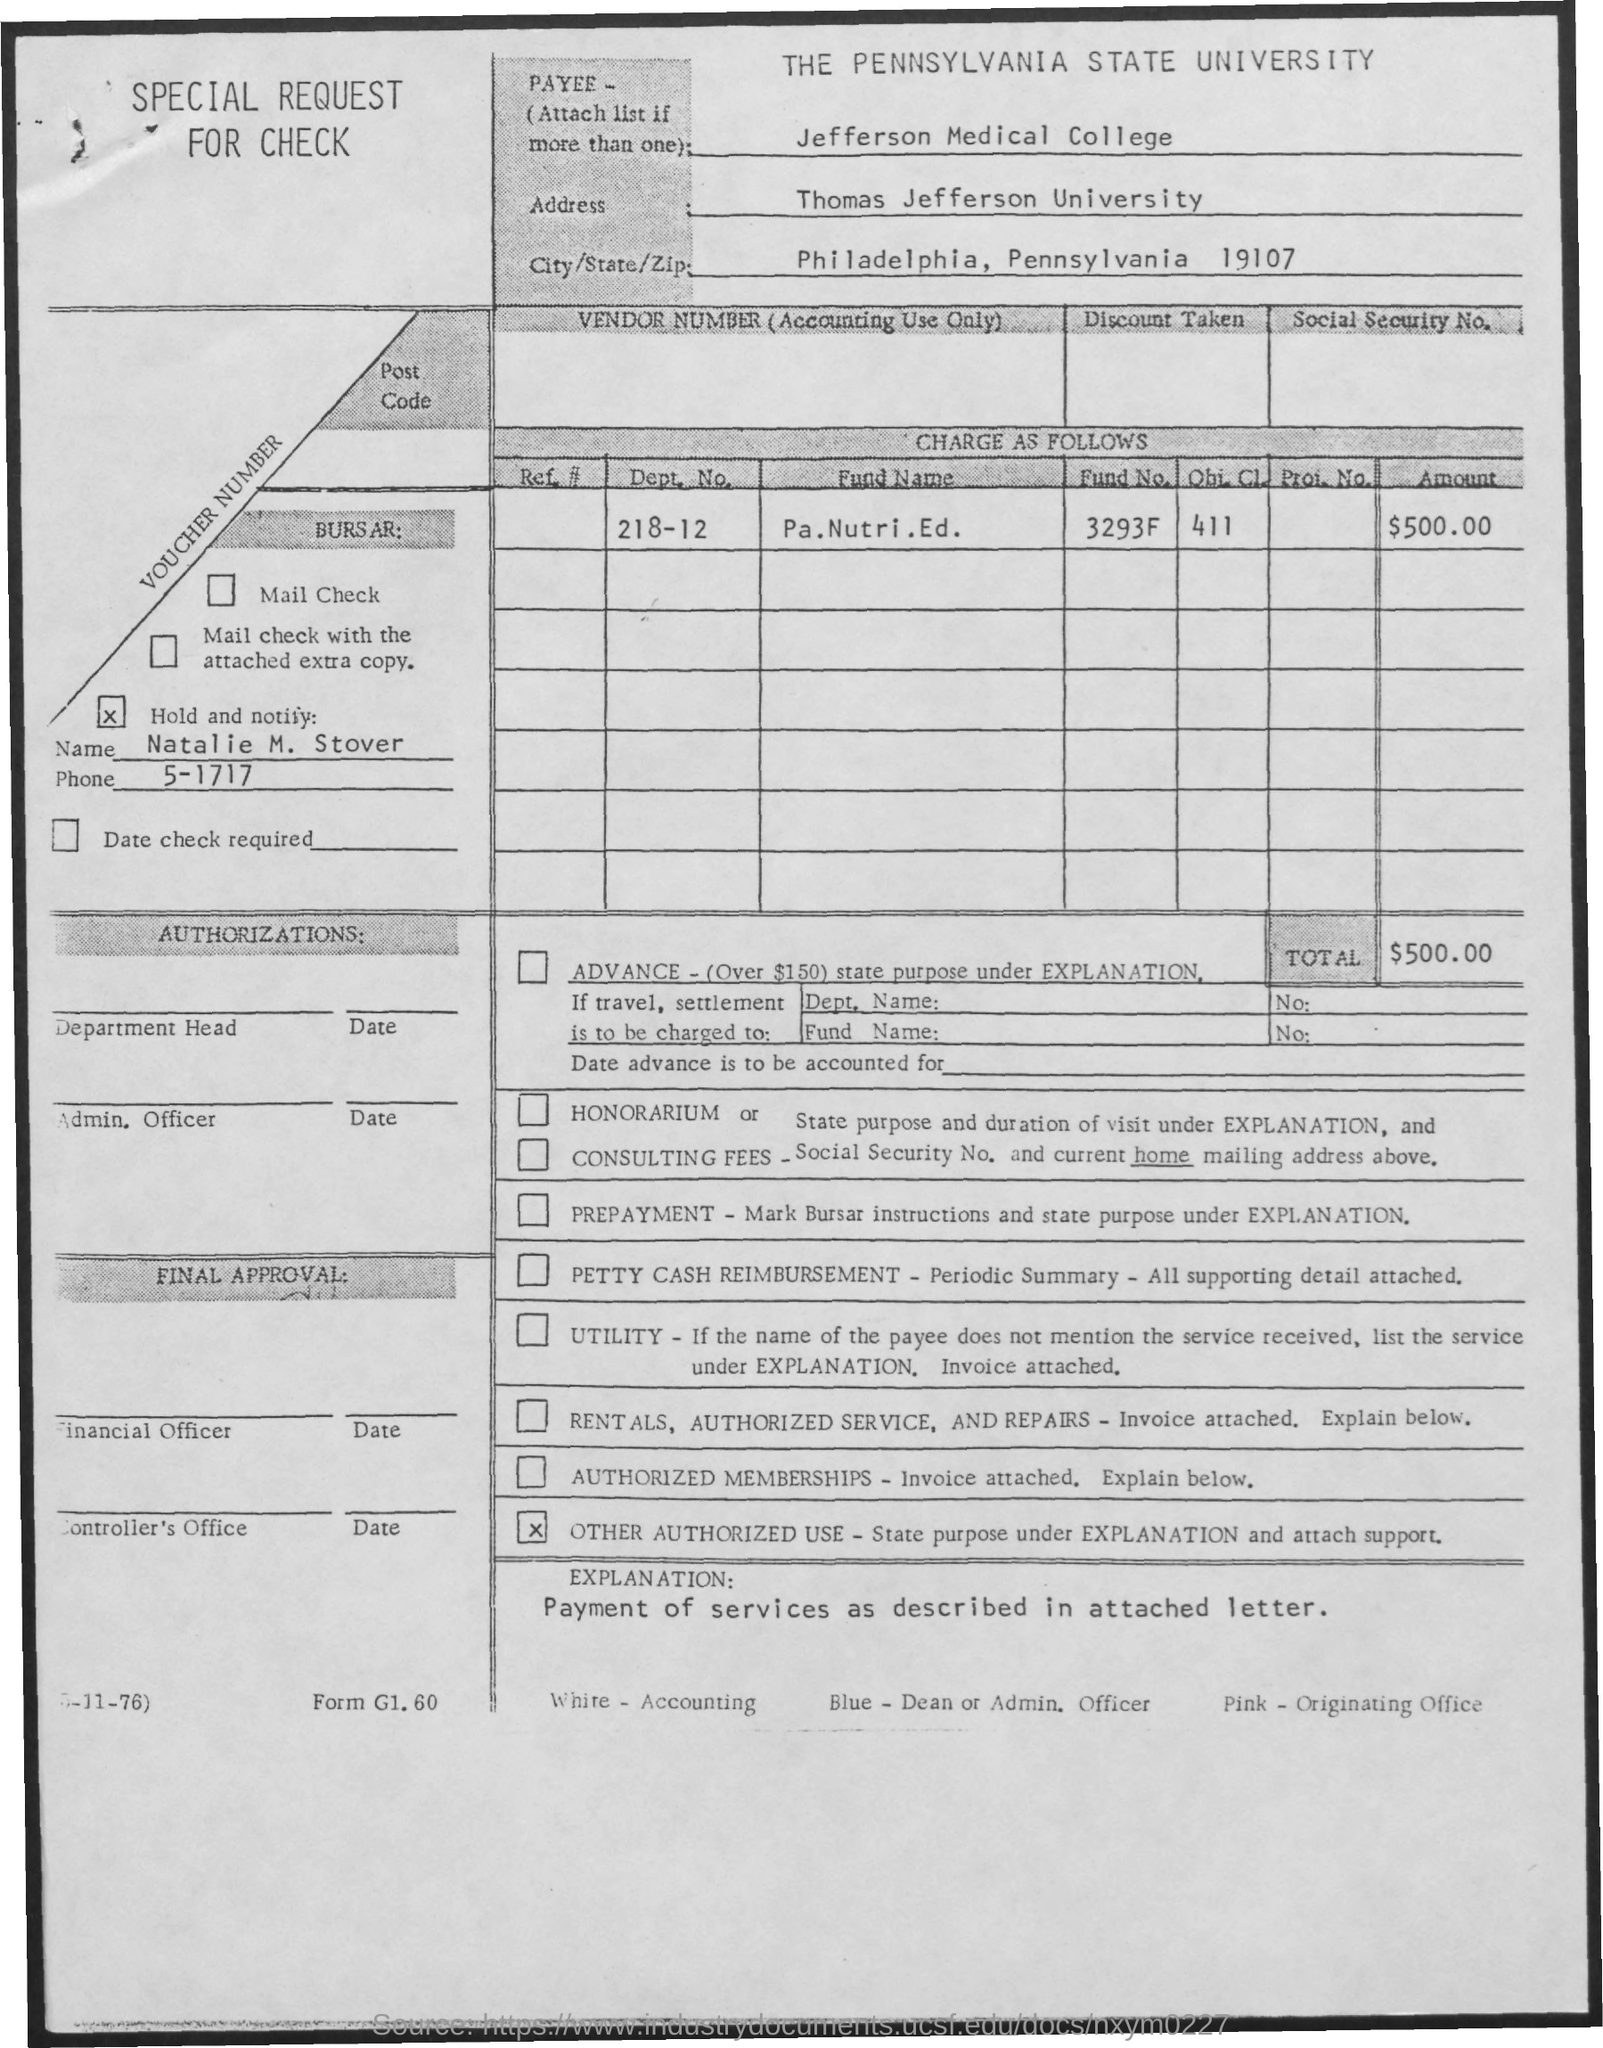What is the dept. no. mentioned ?
Provide a short and direct response. 218-12. What is the fund no. mentioned ?
Provide a short and direct response. 3293F. What is the amount mentioned in the check ?
Offer a very short reply. $500.00. What is the name mentioned in the check ?
Keep it short and to the point. Natalie m. stover. What is the phone no. mentioned ?
Provide a succinct answer. 5-1717. What is the name of the university mentioned in the given address ?
Offer a very short reply. Thomas Jefferson. What is the name of the city mentioned ?
Your answer should be compact. Philadelphia. What is the name of the state mentioned ?
Your response must be concise. Pennsylvania. What is the zip code mentioned ?
Keep it short and to the point. 19107. 